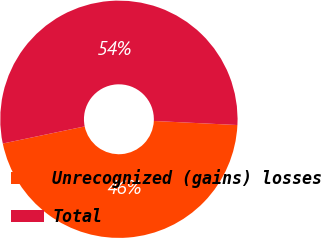Convert chart to OTSL. <chart><loc_0><loc_0><loc_500><loc_500><pie_chart><fcel>Unrecognized (gains) losses<fcel>Total<nl><fcel>45.95%<fcel>54.05%<nl></chart> 